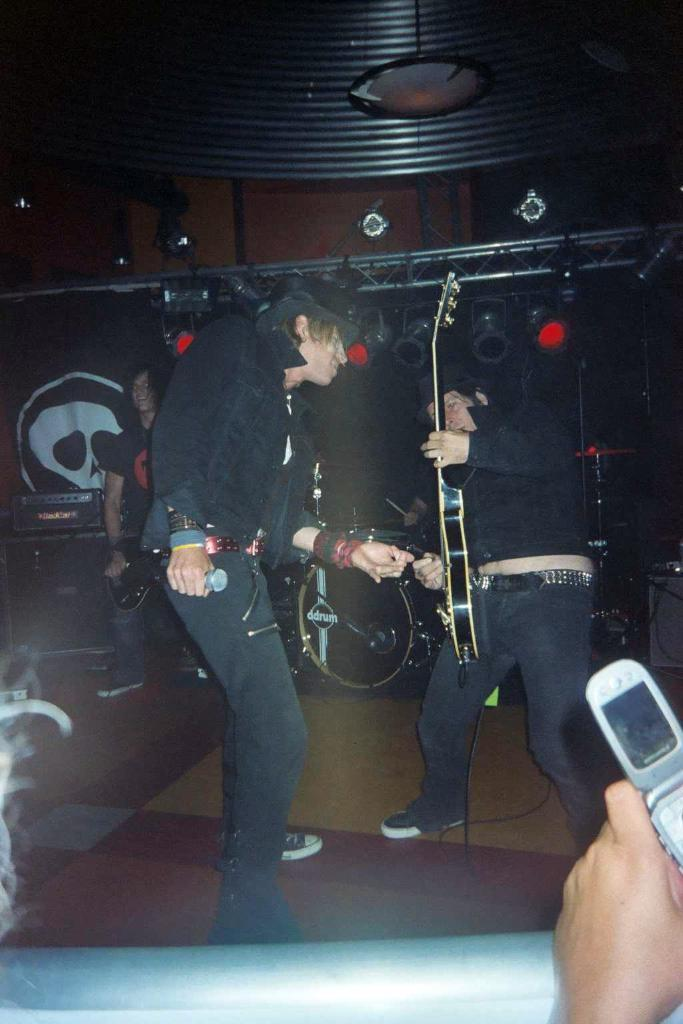How many people are in the image? There are people in the image. What are the people in the image doing? The people are standing. What musical instrument can be seen in the image? One or more people are holding a guitar. What device can be seen in the image that is typically used for amplifying sound? One or more people are holding a microphone. Who is the owner of the page in the image? There is no reference to a page or ownership in the image, so it's not possible to determine who the owner might be. Can you tell me the age of the grandfather in the image? There is no grandfather present in the image. 